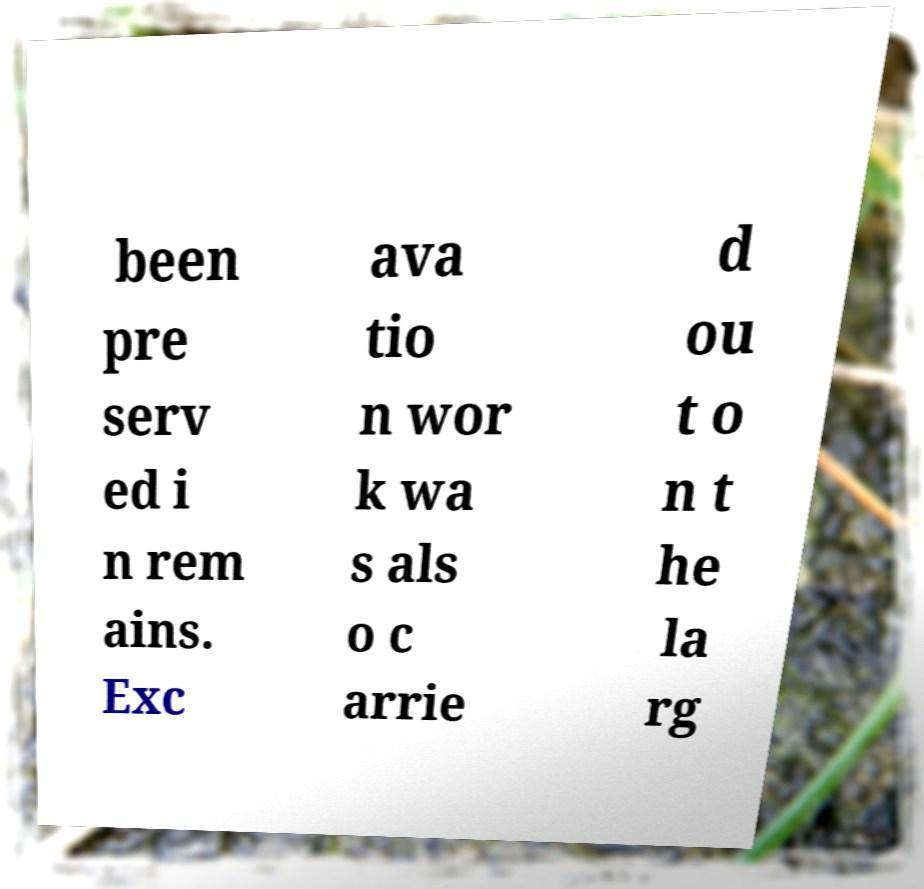I need the written content from this picture converted into text. Can you do that? been pre serv ed i n rem ains. Exc ava tio n wor k wa s als o c arrie d ou t o n t he la rg 